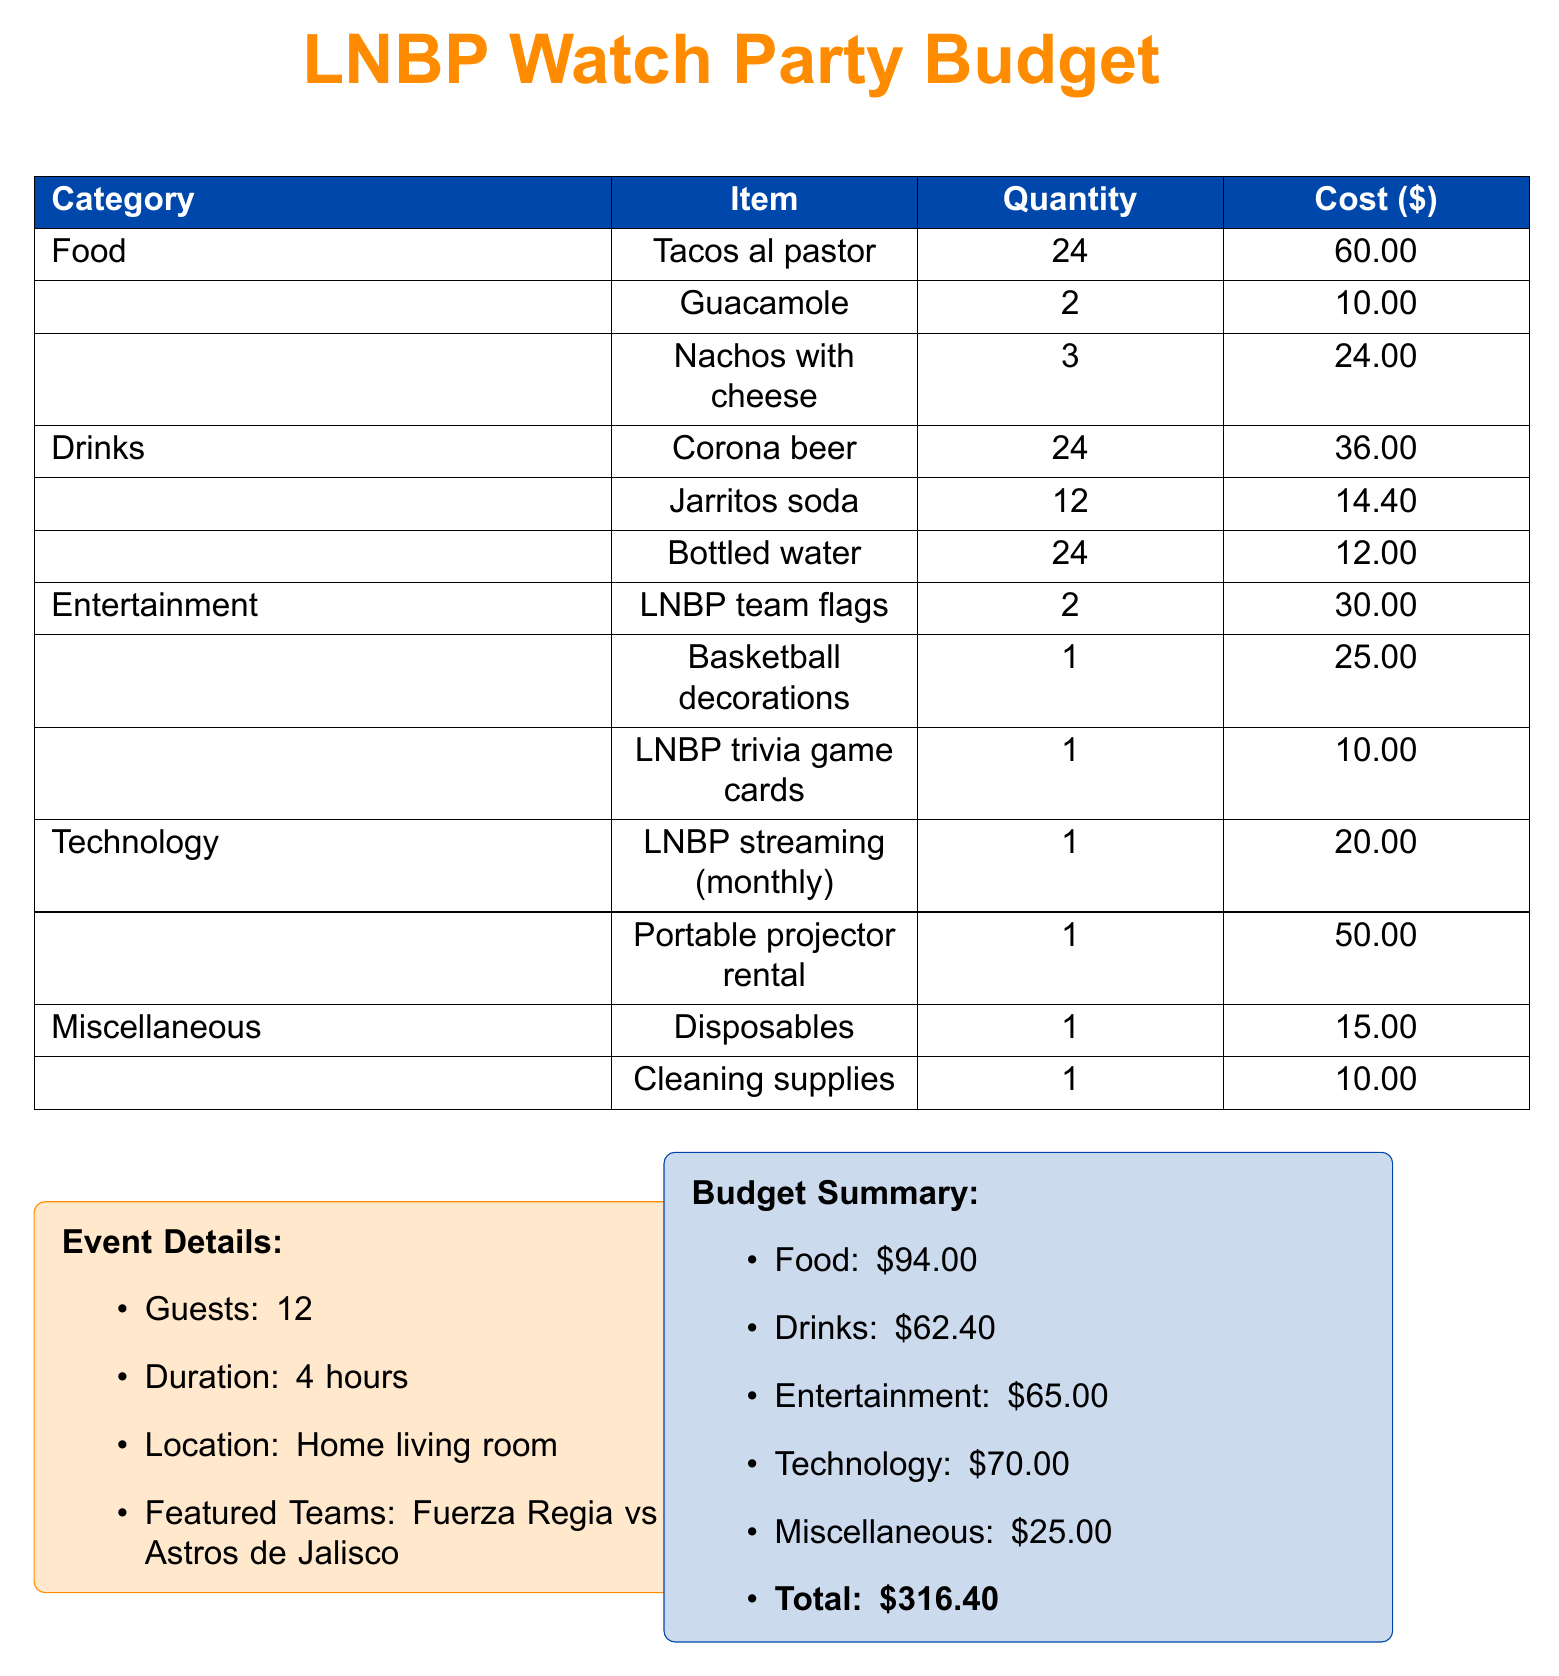What is the total budget for the watch party? The total budget is the sum of all the costs listed in the budget summary, which is 94.00 + 62.40 + 65.00 + 70.00 + 25.00 = 316.40.
Answer: 316.40 How many guests are expected? The document specifies the number of guests attending the event.
Answer: 12 What is the cost of Tacos al pastor? The cost is directly listed under the food category in the document.
Answer: 60.00 How many types of drinks are listed in the budget? The document lists three types of drinks under the drinks category.
Answer: 3 What is the cost of the portable projector rental? The cost is specifically mentioned in the technology section of the budget.
Answer: 50.00 Which teams are featuring in the event? The document provides details about the teams participating in the watch party.
Answer: Fuerza Regia vs Astros de Jalisco What is the total cost for entertainment? The total cost for entertainment is the sum of all items listed in the entertainment category.
Answer: 65.00 How much is allocated for cleaning supplies? The cost for cleaning supplies is explicitly stated in the miscellaneous section.
Answer: 10.00 What is the quantity of Guacamole being ordered? The quantity is specified in the food category in the budget table.
Answer: 2 